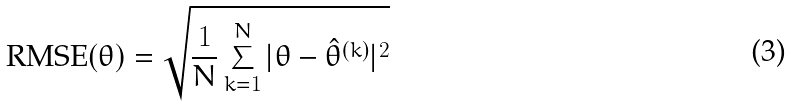Convert formula to latex. <formula><loc_0><loc_0><loc_500><loc_500>\text {RMSE} ( \theta ) = \sqrt { \frac { 1 } { N } \sum _ { k = 1 } ^ { N } | \theta - \hat { \theta } ^ { ( k ) } | ^ { 2 } }</formula> 